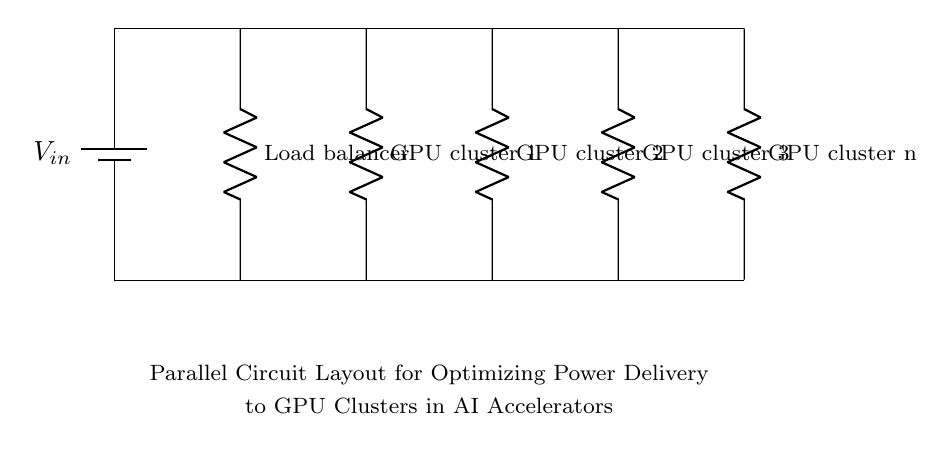what is the source voltage in this circuit? The source voltage is denoted by the label \( V_{in} \) on the battery. It provides the potential difference to power the circuit.
Answer: \( V_{in} \) how many GPU clusters are present in the circuit? The diagram shows four distinct GPU cluster components, labeled from "GPU cluster 1" through "GPU cluster n".
Answer: four what is the function of the load balancer in this circuit? The load balancer distributes the input voltage and current evenly among the parallel branches leading to the GPU clusters. This ensures that each cluster receives an adequate and balanced power supply.
Answer: distribute power what type of circuit configuration is this? The diagram illustrates a parallel circuit configuration, which means that all components (GPU clusters) are connected in parallel to the same voltage source, allowing each to operate independently with the same voltage across them.
Answer: parallel what is the implication of using a parallel circuit for GPU clusters? In a parallel circuit, each GPU cluster receives the same voltage, leading to improved system reliability and efficiency, as a failure in one cluster does not impact the others. This configuration is beneficial for maximizing power delivery to multiple processing units.
Answer: efficient power delivery if one GPU cluster fails, what happens to the other clusters? In a parallel circuit, if one cluster fails, the other clusters continue to receive the same voltage and operate normally. This setup enhances overall system resilience as individual cluster failures do not affect the performance of the remaining ones.
Answer: remain operational 